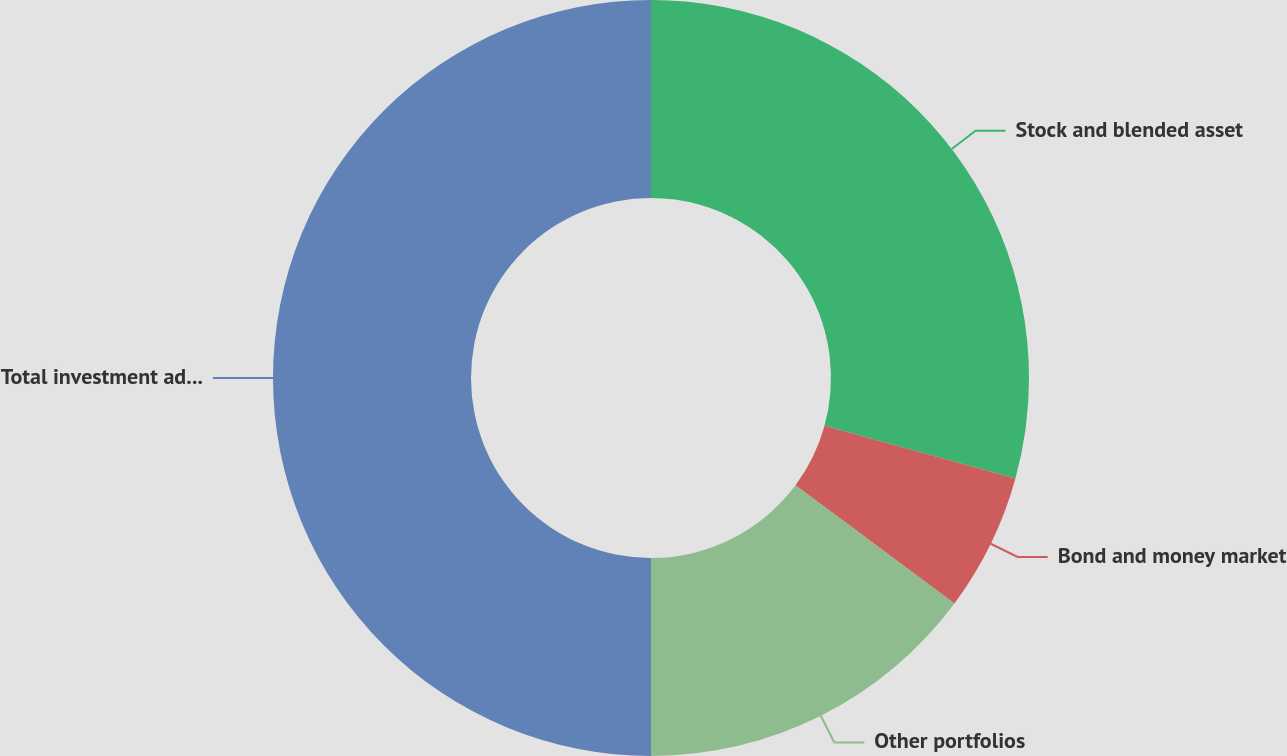Convert chart. <chart><loc_0><loc_0><loc_500><loc_500><pie_chart><fcel>Stock and blended asset<fcel>Bond and money market<fcel>Other portfolios<fcel>Total investment advisory fees<nl><fcel>29.28%<fcel>5.89%<fcel>14.83%<fcel>50.0%<nl></chart> 